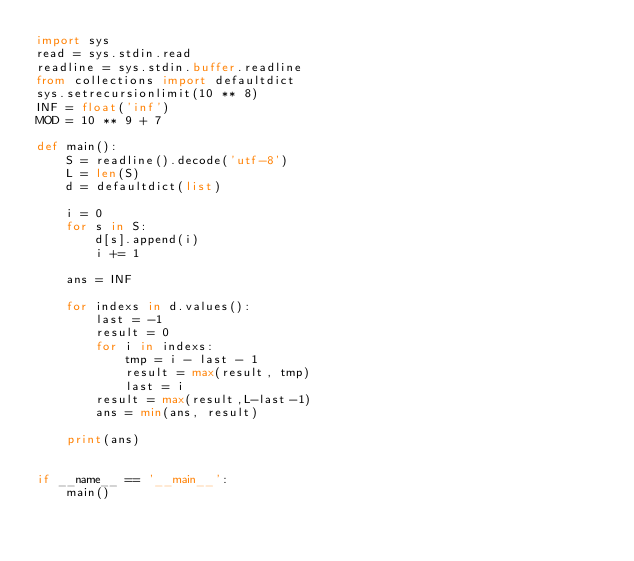Convert code to text. <code><loc_0><loc_0><loc_500><loc_500><_Python_>import sys
read = sys.stdin.read
readline = sys.stdin.buffer.readline
from collections import defaultdict
sys.setrecursionlimit(10 ** 8)
INF = float('inf')
MOD = 10 ** 9 + 7

def main():
    S = readline().decode('utf-8')
    L = len(S)
    d = defaultdict(list)

    i = 0
    for s in S:
        d[s].append(i)
        i += 1

    ans = INF

    for indexs in d.values():
        last = -1
        result = 0
        for i in indexs:
            tmp = i - last - 1
            result = max(result, tmp)
            last = i
        result = max(result,L-last-1)
        ans = min(ans, result)

    print(ans)


if __name__ == '__main__':
    main()
</code> 